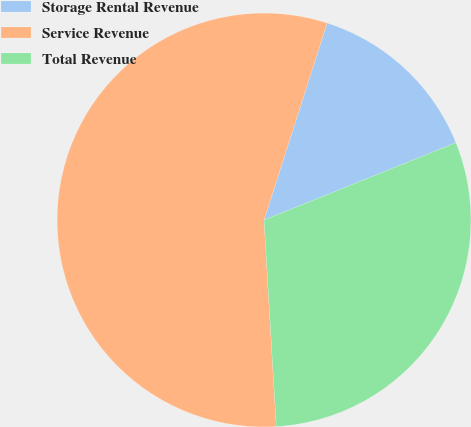Convert chart. <chart><loc_0><loc_0><loc_500><loc_500><pie_chart><fcel>Storage Rental Revenue<fcel>Service Revenue<fcel>Total Revenue<nl><fcel>13.97%<fcel>55.88%<fcel>30.15%<nl></chart> 